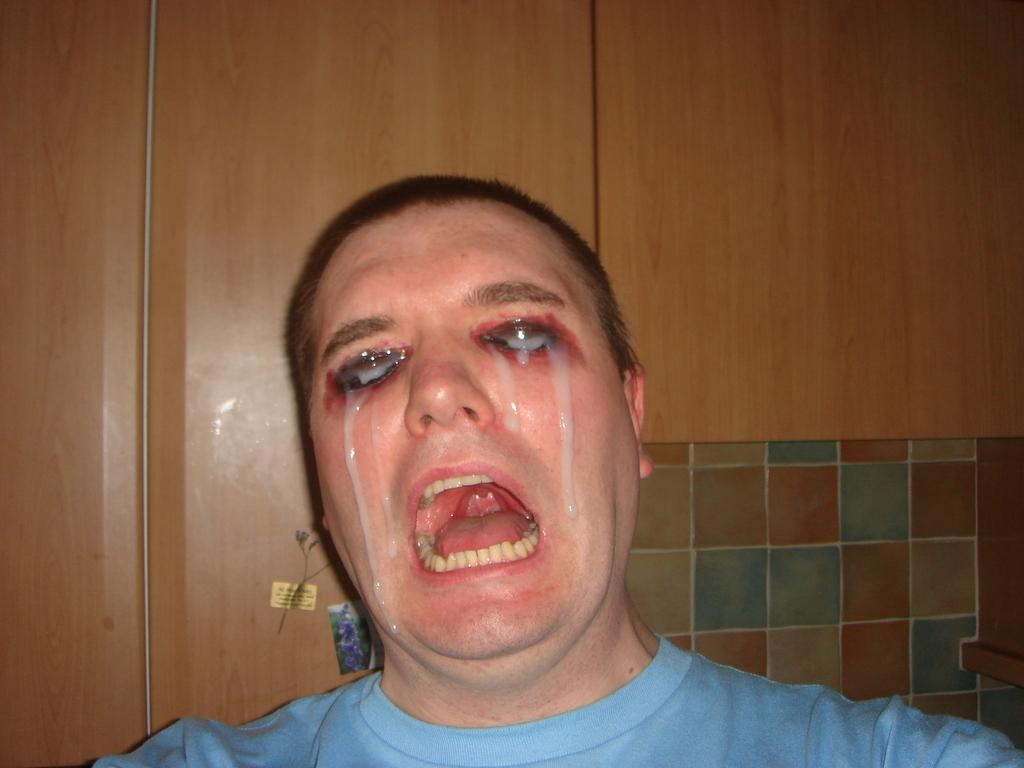Who or what is present in the image? There is a person in the image. What can be seen behind the person? There is a wooden frame behind the person. How many oranges are on the wooden frame in the image? There are no oranges present in the image. Is there a volleyball game happening in the image? There is no indication of a volleyball game in the image. Are there any spiders visible on the wooden frame in the image? There are no spiders visible on the wooden frame in the image. 